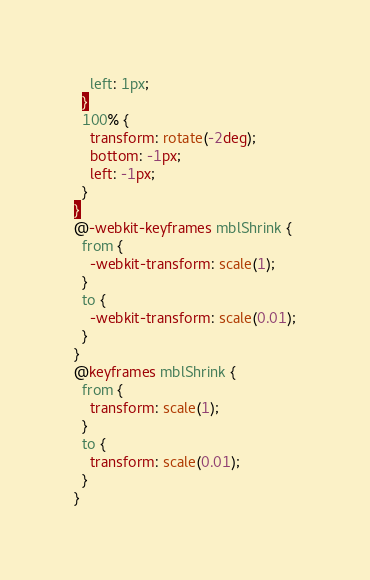Convert code to text. <code><loc_0><loc_0><loc_500><loc_500><_CSS_>    left: 1px;
  }
  100% {
    transform: rotate(-2deg);
    bottom: -1px;
    left: -1px;
  }
}
@-webkit-keyframes mblShrink {
  from {
    -webkit-transform: scale(1);
  }
  to {
    -webkit-transform: scale(0.01);
  }
}
@keyframes mblShrink {
  from {
    transform: scale(1);
  }
  to {
    transform: scale(0.01);
  }
}</code> 